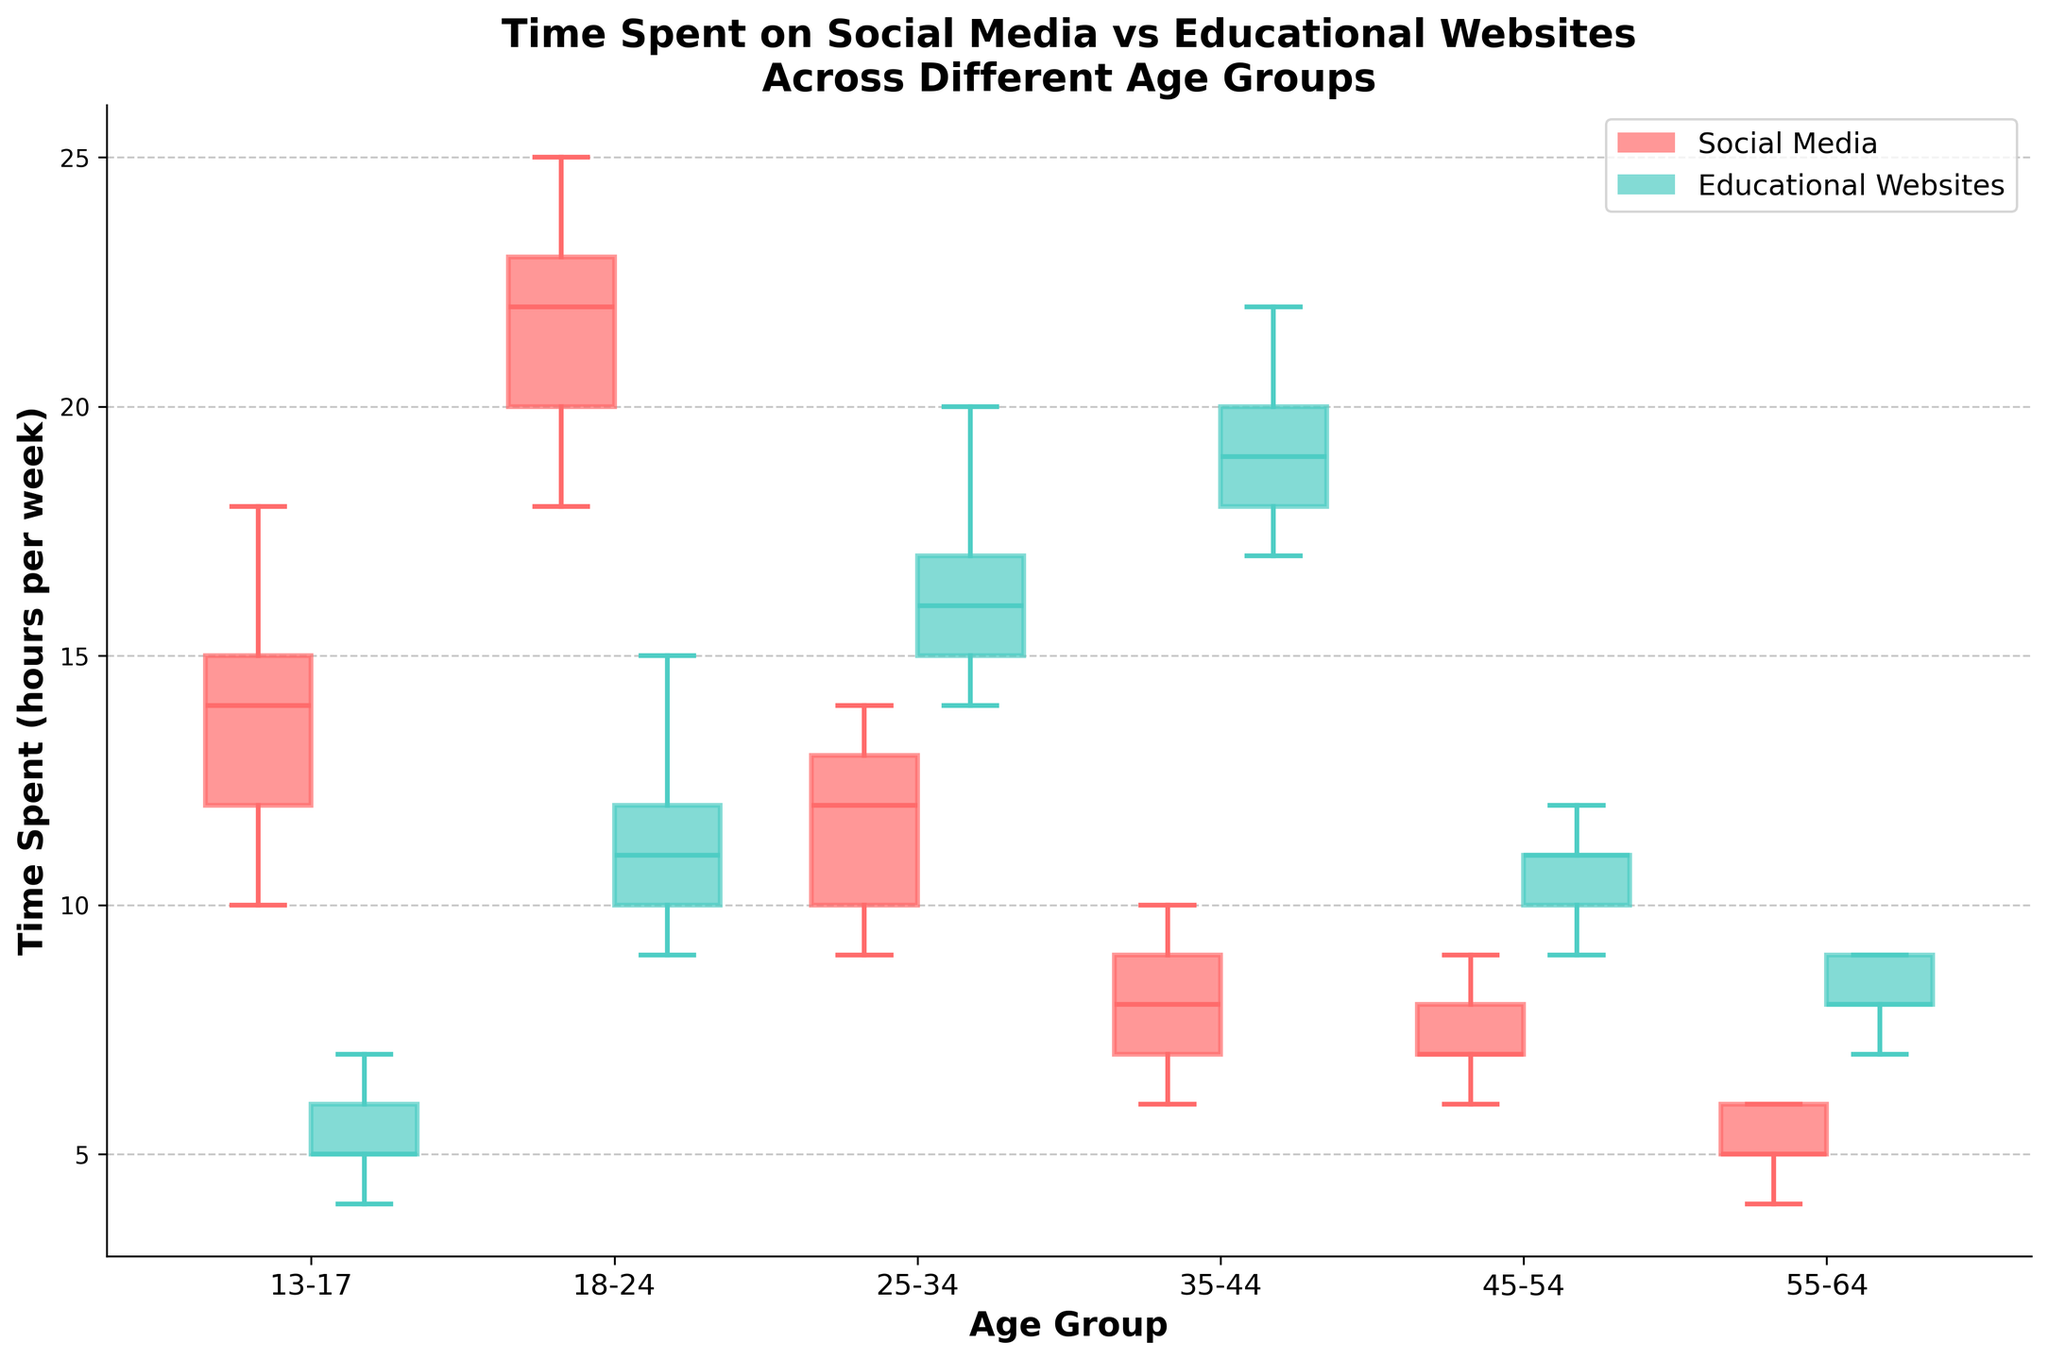What is the title of the figure? The title can be found at the top center of the figure where it summarizes the visualized data.
Answer: Time Spent on Social Media vs Educational Websites Across Different Age Groups What are the two platforms compared in the figure? The platforms are identified in the legend located at the upper right corner of the figure, distinguished by their colors.
Answer: Social Media and Educational Websites How do the medians of time spent on Social Media compare between the 13-17 and 18-24 age groups? Locate the median lines inside the box plot for Social Media for both age groups: The 13-17 median is around 14 hours, and the 18-24 median is about 22 hours. Compare these values.
Answer: The 18-24 group spends more time Which age group spends the least time on Social Media based on the medians? Identify the median lines for Social Media in each age group. The lowest median indicates the least time spent.
Answer: 55-64 What is the average time spent on Educational Websites by the 25-34 age group? Calculate the average using the mid-points of the box plot (mean is often marked differently) of Educational Websites for ages 25-34. The approximate values are 15, 17, 20, 14, 16. Average: (15+17+20+14+16)/5 = 82/5.
Answer: 16.4 How does the spread of data (interquartile range) for Educational Websites in the 18-24 age group compare to the 35-44 age group? The spread (IQR) is the distance between the first and third quartiles (boxes' top and bottom). Identify and compare these ranges for both age groups.
Answer: 18-24 has a smaller IQR Which platform shows a more significant decrease in usage as age increases from 13-17 to 55-64? Observe the trends in the median lines for both platforms across age groups and note which has a more consistent and steep decrease.
Answer: Social Media For the 45-54 age group, does the time spent on Social Media or Educational Websites have a wider spread? Compare the length of the boxes for both platforms in the 45-54 age group to determine which has the larger interquartile range.
Answer: Educational Websites Is there any age group where the time spent on Educational Websites is consistently higher than on Social Media? Compare the medians (middle lines) for each age group to see if Educational Websites are consistently higher than Social Media. For each group, compare the central lines.
Answer: 25-34, 35-44, and 55-64 What color is used to represent Social Media in the box plots? The legend in the upper right corner links the platforms to their colors, where Social Media is represented.
Answer: Red 